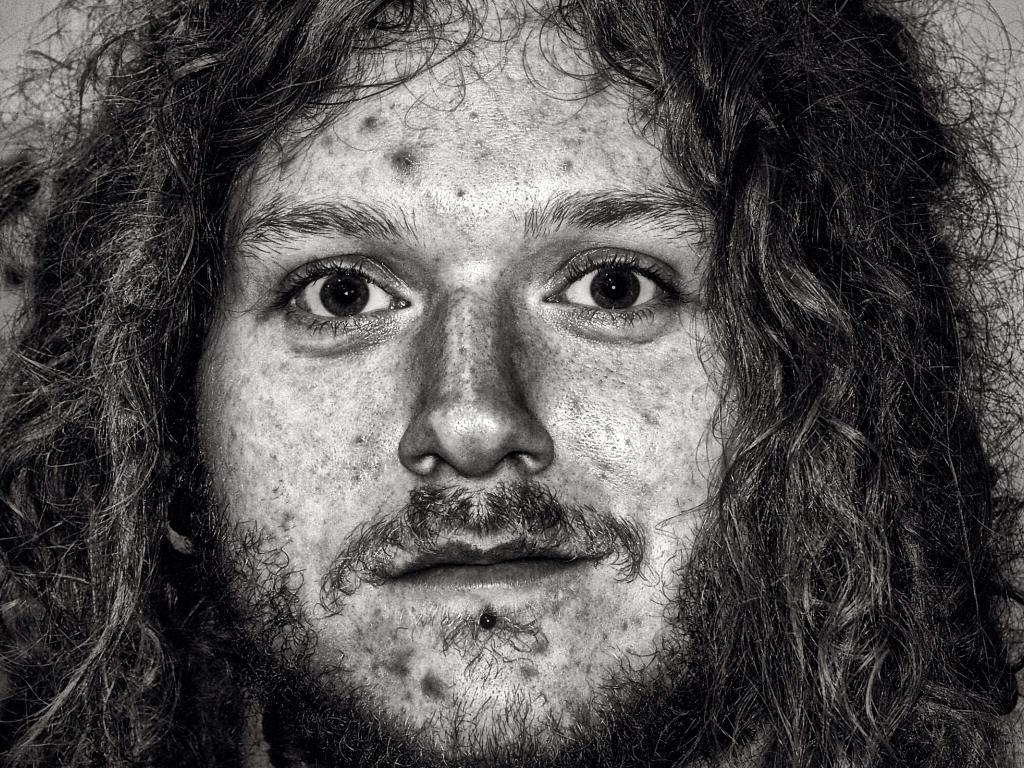What is the color scheme of the image? The image is black and white. What is the main subject of the image? There is a man's face in the image. What facial hair does the man have? The man has a mustache and a beard. Does the man have any hair on his head? Yes, the man has hair. How many flags are visible in the image? There are no flags present in the image. What type of pigs can be seen interacting with the man in the image? There are no pigs present in the image. 